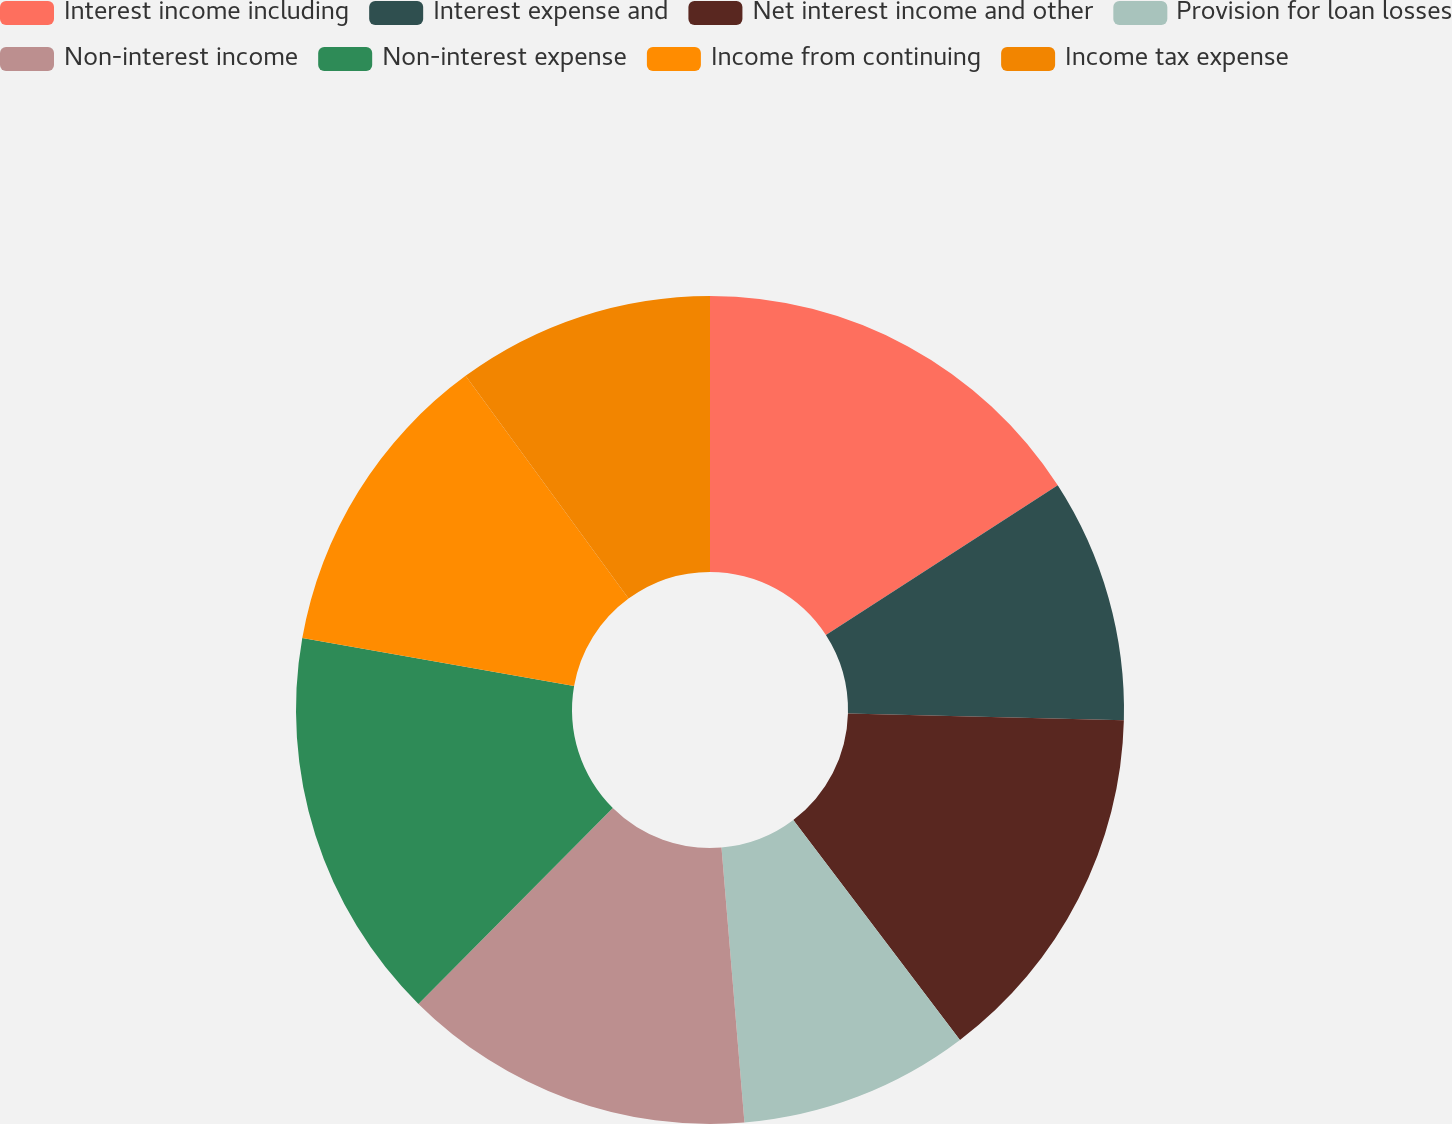Convert chart. <chart><loc_0><loc_0><loc_500><loc_500><pie_chart><fcel>Interest income including<fcel>Interest expense and<fcel>Net interest income and other<fcel>Provision for loan losses<fcel>Non-interest income<fcel>Non-interest expense<fcel>Income from continuing<fcel>Income tax expense<nl><fcel>15.87%<fcel>9.52%<fcel>14.29%<fcel>8.99%<fcel>13.76%<fcel>15.34%<fcel>12.17%<fcel>10.05%<nl></chart> 